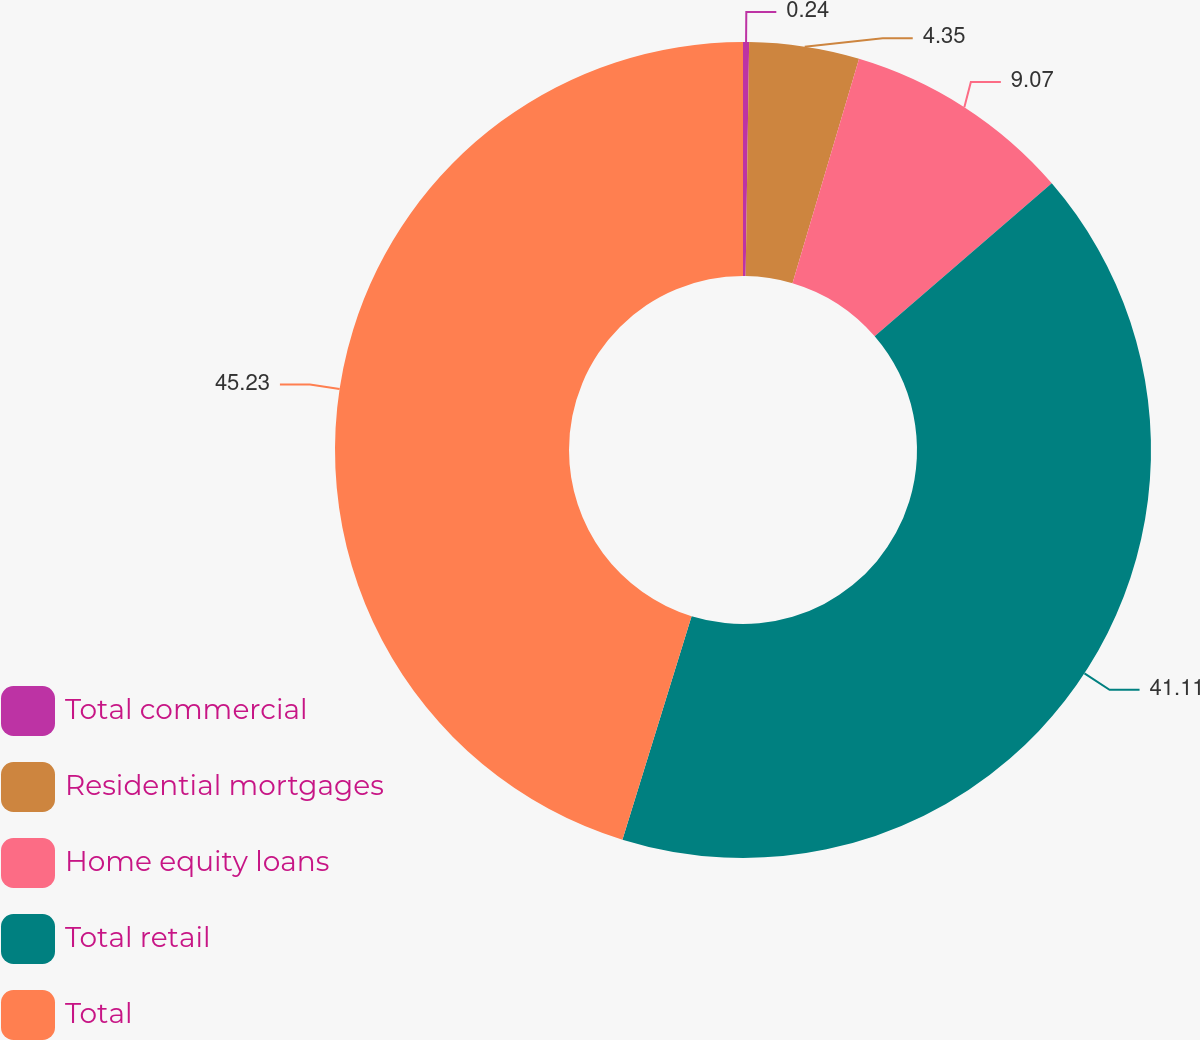Convert chart. <chart><loc_0><loc_0><loc_500><loc_500><pie_chart><fcel>Total commercial<fcel>Residential mortgages<fcel>Home equity loans<fcel>Total retail<fcel>Total<nl><fcel>0.24%<fcel>4.35%<fcel>9.07%<fcel>41.11%<fcel>45.22%<nl></chart> 